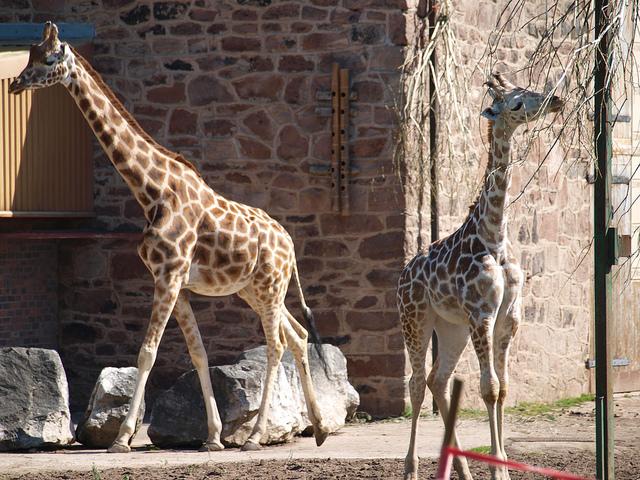Where might the giraffes be?
Give a very brief answer. Zoo. Which giraffe is younger?
Quick response, please. One on right. Are the animals in their own habitat?
Quick response, please. No. 